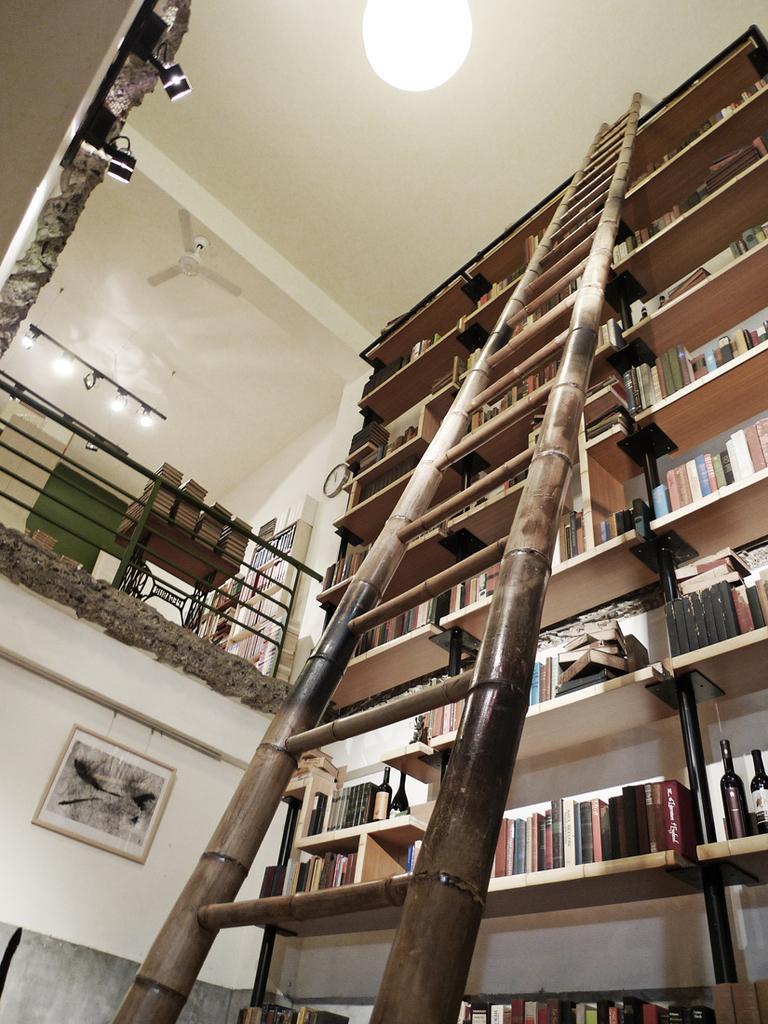Please provide a concise description of this image. In the image we can see there is a wooden ladder and there are lot of books kept in the racks. There are wine bottles kept in the rack and there are lights on the top. There is fan kept on the top. 